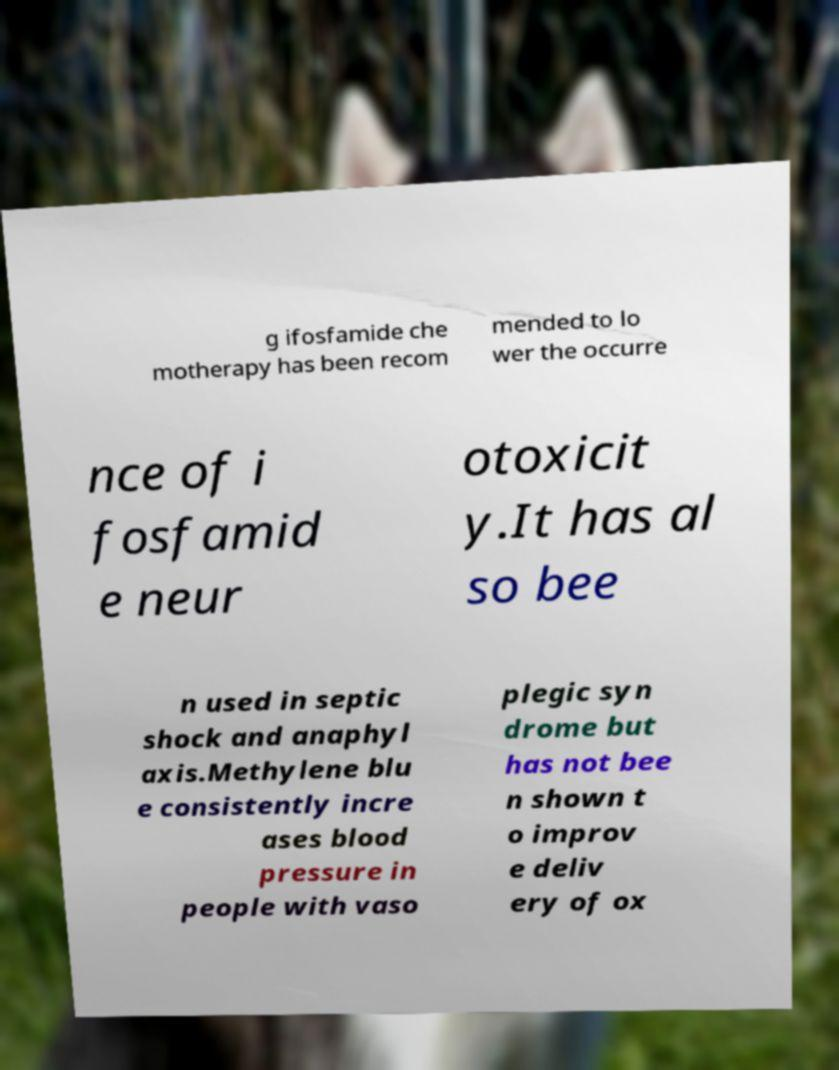Could you extract and type out the text from this image? g ifosfamide che motherapy has been recom mended to lo wer the occurre nce of i fosfamid e neur otoxicit y.It has al so bee n used in septic shock and anaphyl axis.Methylene blu e consistently incre ases blood pressure in people with vaso plegic syn drome but has not bee n shown t o improv e deliv ery of ox 